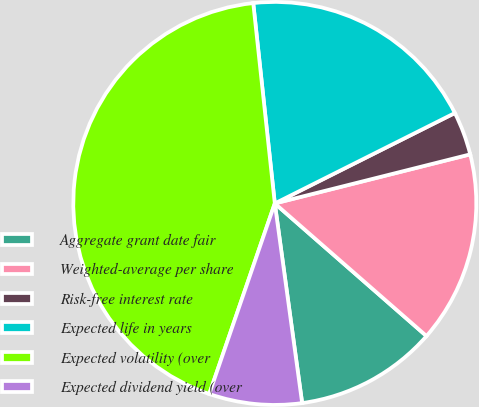<chart> <loc_0><loc_0><loc_500><loc_500><pie_chart><fcel>Aggregate grant date fair<fcel>Weighted-average per share<fcel>Risk-free interest rate<fcel>Expected life in years<fcel>Expected volatility (over<fcel>Expected dividend yield (over<nl><fcel>11.4%<fcel>15.35%<fcel>3.49%<fcel>19.3%<fcel>43.02%<fcel>7.44%<nl></chart> 